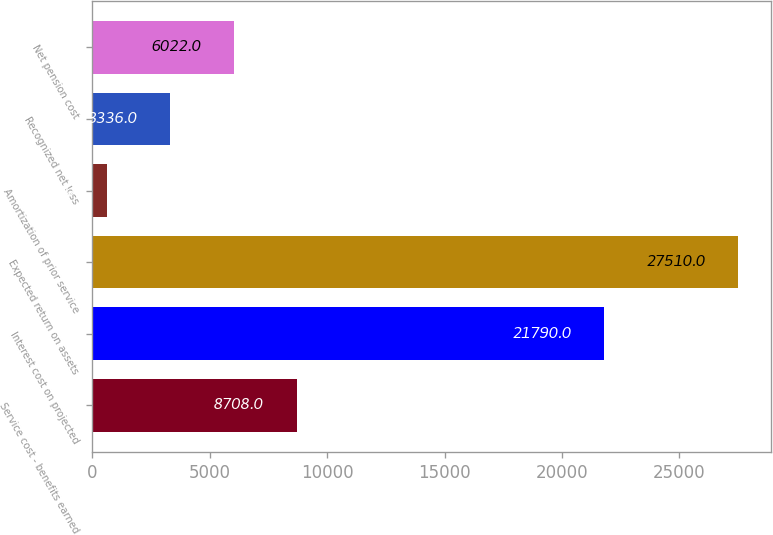Convert chart to OTSL. <chart><loc_0><loc_0><loc_500><loc_500><bar_chart><fcel>Service cost - benefits earned<fcel>Interest cost on projected<fcel>Expected return on assets<fcel>Amortization of prior service<fcel>Recognized net loss<fcel>Net pension cost<nl><fcel>8708<fcel>21790<fcel>27510<fcel>650<fcel>3336<fcel>6022<nl></chart> 